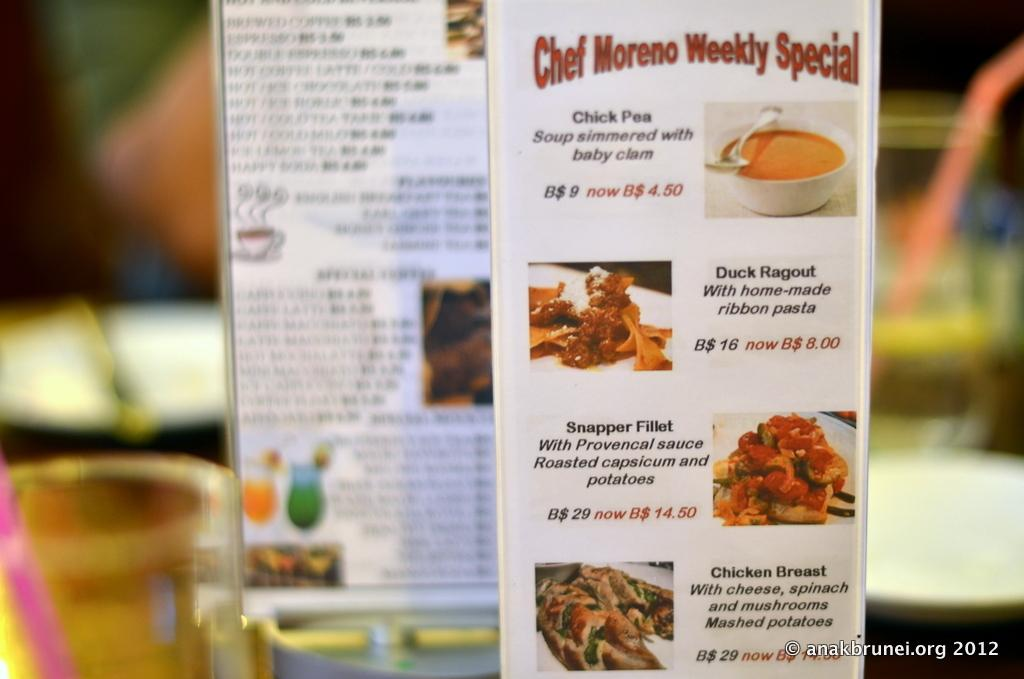<image>
Relay a brief, clear account of the picture shown. A printed menu featuring a variety of items including seafood. 